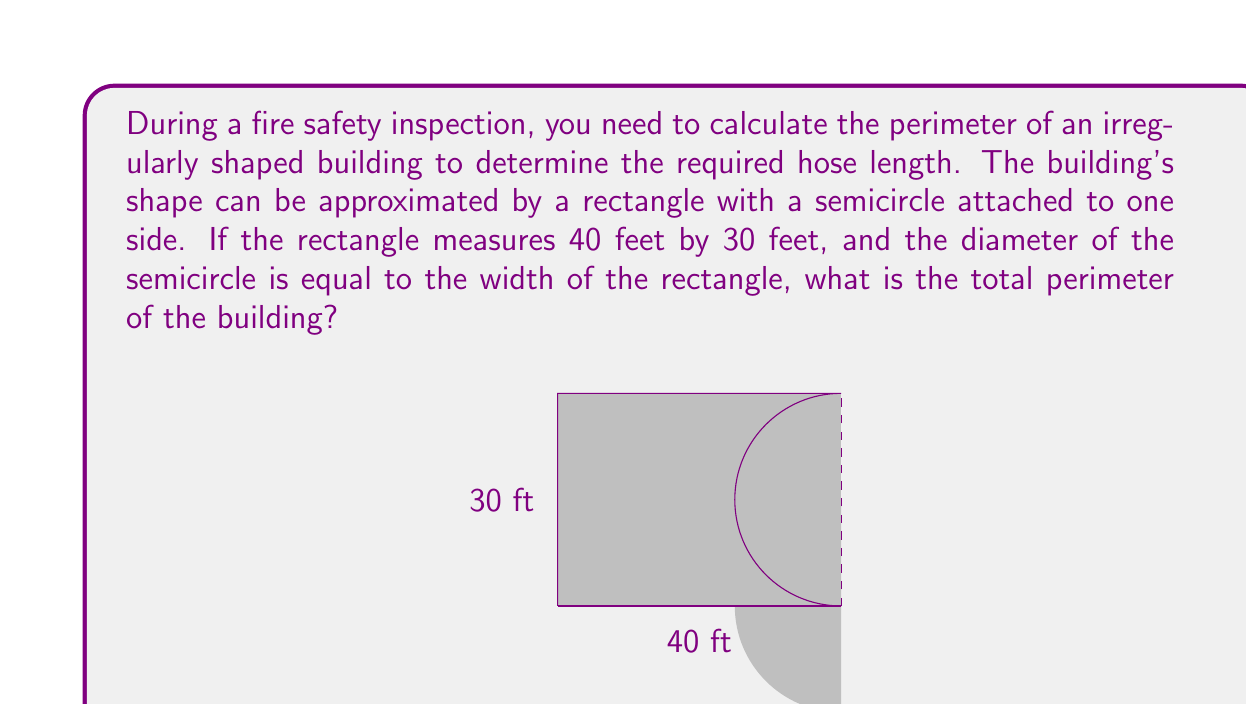Help me with this question. Let's break this down step-by-step:

1) First, let's identify the parts we need to calculate:
   - Perimeter of the rectangle (excluding the side with the semicircle)
   - Circumference of the semicircle

2) For the rectangle:
   - Length = 40 feet
   - Width = 30 feet
   - Perimeter (excluding one long side) = $40 + 30 + 30 = 100$ feet

3) For the semicircle:
   - Diameter = Width of rectangle = 30 feet
   - Radius = 15 feet
   - Circumference of a full circle = $2\pi r$
   - Semicircle is half of this, so: $\pi r$

4) Calculate the semicircle portion:
   $$\pi r = \pi \cdot 15 \approx 47.12 \text{ feet}$$

5) Total perimeter:
   Rectangle portion + Semicircle portion
   $$100 + 47.12 = 147.12 \text{ feet}$$

6) Rounding to the nearest foot for practical purposes:
   $$147.12 \approx 147 \text{ feet}$$

Therefore, you would need approximately 147 feet of hose to surround the entire building.
Answer: 147 feet 